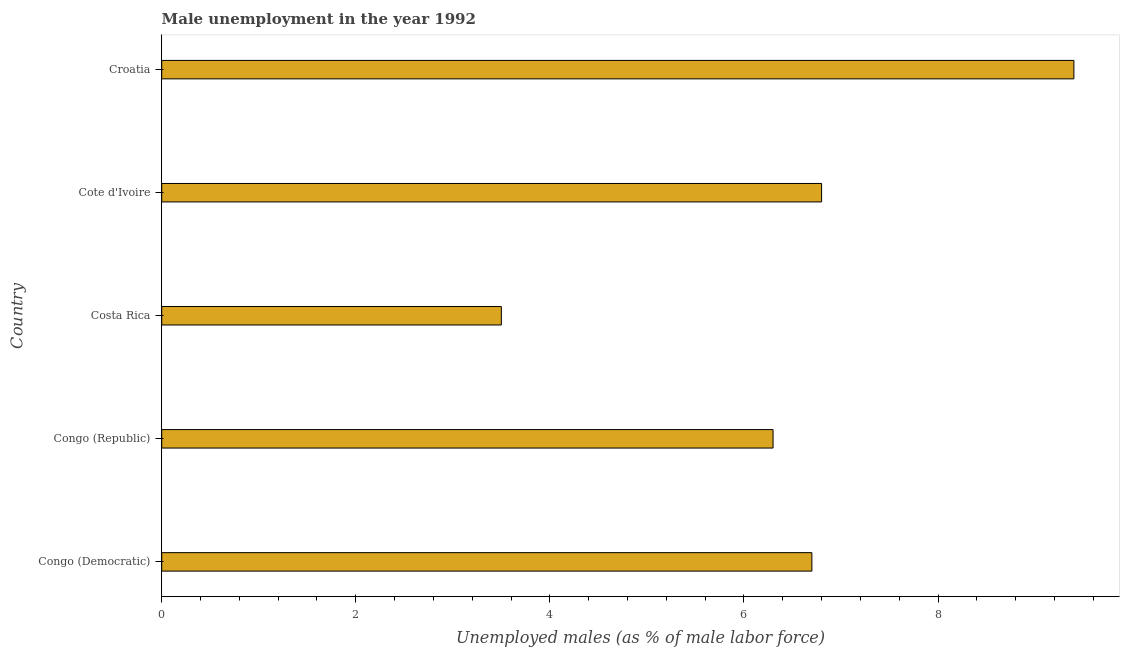Does the graph contain any zero values?
Provide a short and direct response. No. What is the title of the graph?
Ensure brevity in your answer.  Male unemployment in the year 1992. What is the label or title of the X-axis?
Provide a short and direct response. Unemployed males (as % of male labor force). What is the unemployed males population in Congo (Republic)?
Offer a terse response. 6.3. Across all countries, what is the maximum unemployed males population?
Your answer should be very brief. 9.4. Across all countries, what is the minimum unemployed males population?
Make the answer very short. 3.5. In which country was the unemployed males population maximum?
Offer a terse response. Croatia. In which country was the unemployed males population minimum?
Offer a very short reply. Costa Rica. What is the sum of the unemployed males population?
Provide a succinct answer. 32.7. What is the average unemployed males population per country?
Give a very brief answer. 6.54. What is the median unemployed males population?
Make the answer very short. 6.7. What is the ratio of the unemployed males population in Cote d'Ivoire to that in Croatia?
Your answer should be compact. 0.72. Is the sum of the unemployed males population in Congo (Democratic) and Croatia greater than the maximum unemployed males population across all countries?
Offer a terse response. Yes. Are all the bars in the graph horizontal?
Provide a succinct answer. Yes. How many countries are there in the graph?
Offer a very short reply. 5. What is the difference between two consecutive major ticks on the X-axis?
Offer a very short reply. 2. What is the Unemployed males (as % of male labor force) in Congo (Democratic)?
Ensure brevity in your answer.  6.7. What is the Unemployed males (as % of male labor force) of Congo (Republic)?
Your response must be concise. 6.3. What is the Unemployed males (as % of male labor force) in Cote d'Ivoire?
Your response must be concise. 6.8. What is the Unemployed males (as % of male labor force) in Croatia?
Provide a short and direct response. 9.4. What is the difference between the Unemployed males (as % of male labor force) in Congo (Republic) and Costa Rica?
Your response must be concise. 2.8. What is the difference between the Unemployed males (as % of male labor force) in Congo (Republic) and Cote d'Ivoire?
Offer a terse response. -0.5. What is the difference between the Unemployed males (as % of male labor force) in Congo (Republic) and Croatia?
Your response must be concise. -3.1. What is the difference between the Unemployed males (as % of male labor force) in Costa Rica and Cote d'Ivoire?
Keep it short and to the point. -3.3. What is the difference between the Unemployed males (as % of male labor force) in Costa Rica and Croatia?
Keep it short and to the point. -5.9. What is the ratio of the Unemployed males (as % of male labor force) in Congo (Democratic) to that in Congo (Republic)?
Offer a very short reply. 1.06. What is the ratio of the Unemployed males (as % of male labor force) in Congo (Democratic) to that in Costa Rica?
Ensure brevity in your answer.  1.91. What is the ratio of the Unemployed males (as % of male labor force) in Congo (Democratic) to that in Cote d'Ivoire?
Ensure brevity in your answer.  0.98. What is the ratio of the Unemployed males (as % of male labor force) in Congo (Democratic) to that in Croatia?
Keep it short and to the point. 0.71. What is the ratio of the Unemployed males (as % of male labor force) in Congo (Republic) to that in Costa Rica?
Provide a short and direct response. 1.8. What is the ratio of the Unemployed males (as % of male labor force) in Congo (Republic) to that in Cote d'Ivoire?
Give a very brief answer. 0.93. What is the ratio of the Unemployed males (as % of male labor force) in Congo (Republic) to that in Croatia?
Provide a short and direct response. 0.67. What is the ratio of the Unemployed males (as % of male labor force) in Costa Rica to that in Cote d'Ivoire?
Offer a terse response. 0.52. What is the ratio of the Unemployed males (as % of male labor force) in Costa Rica to that in Croatia?
Offer a very short reply. 0.37. What is the ratio of the Unemployed males (as % of male labor force) in Cote d'Ivoire to that in Croatia?
Keep it short and to the point. 0.72. 